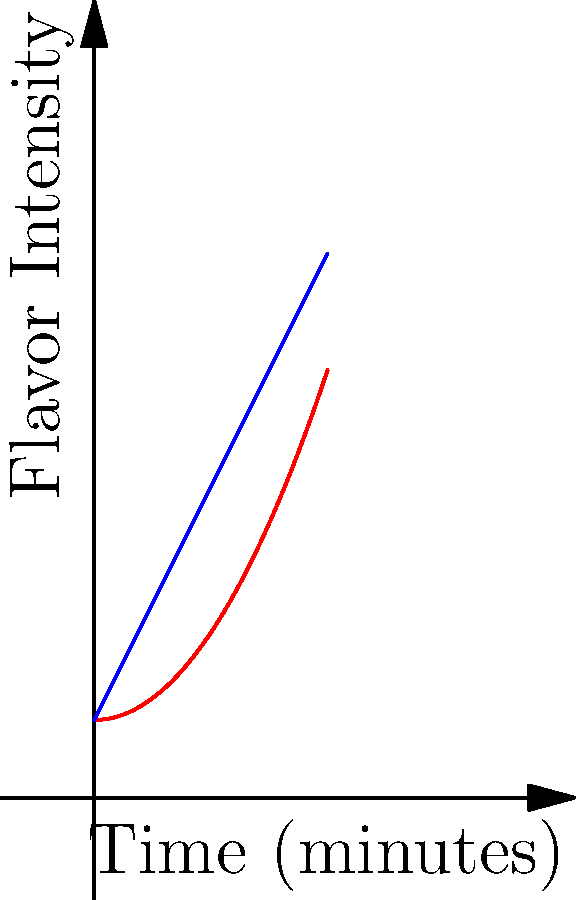A master distiller is analyzing the flavor profile of a rare brandy. The red curve represents the intensity of vanilla notes, given by $f(x) = 0.5x^2 + 1$, while the blue curve represents the intensity of oak notes, given by $g(x) = 2x + 1$, where $x$ is the time in minutes during a 3-minute tasting. Calculate the difference between the areas under these two curves from 0 to 3 minutes, representing the overall dominance of one flavor over the other. To solve this problem, we need to follow these steps:

1) First, we need to find the area under each curve separately using definite integrals.

2) For the vanilla curve (red):
   $$A_v = \int_0^3 (0.5x^2 + 1) dx = [0.5 \cdot \frac{x^3}{3} + x]_0^3 = (4.5 + 3) - (0 + 0) = 7.5$$

3) For the oak curve (blue):
   $$A_o = \int_0^3 (2x + 1) dx = [x^2 + x]_0^3 = (9 + 3) - (0 + 0) = 12$$

4) Now, we need to find the difference between these areas:
   $$A_o - A_v = 12 - 7.5 = 4.5$$

5) This positive result indicates that the area under the oak curve is larger, suggesting that oak flavors dominate over vanilla in this brandy's profile.
Answer: 4.5 square units 